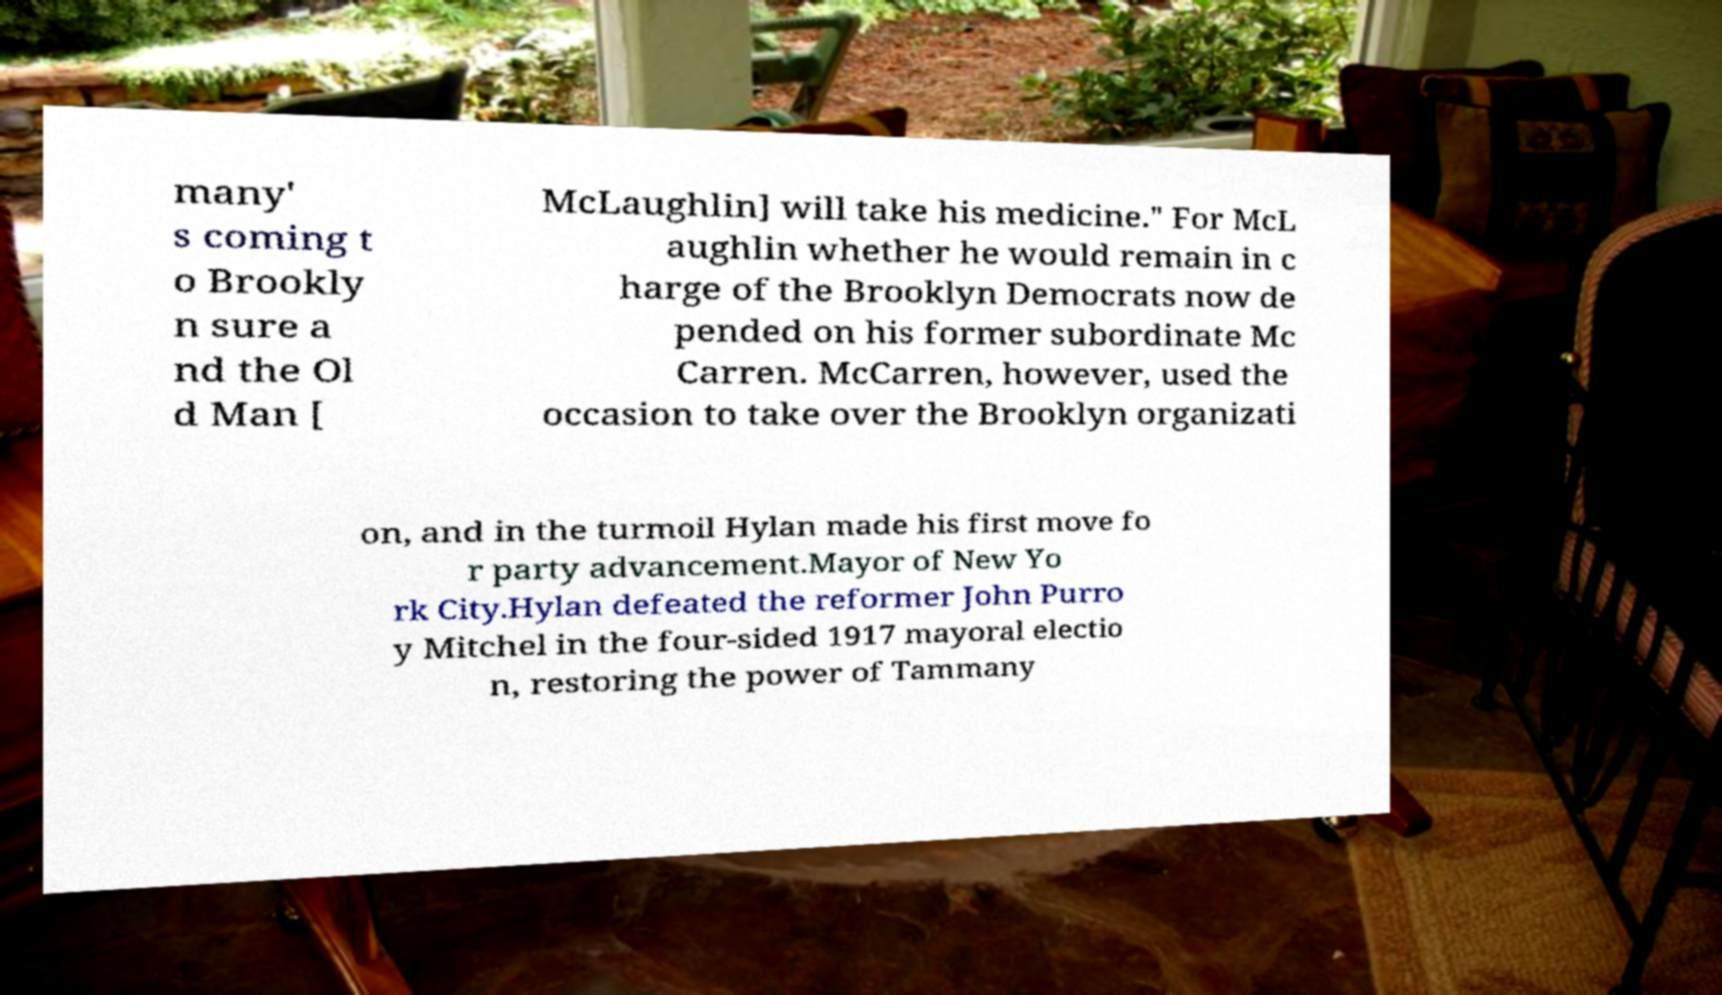There's text embedded in this image that I need extracted. Can you transcribe it verbatim? many' s coming t o Brookly n sure a nd the Ol d Man [ McLaughlin] will take his medicine." For McL aughlin whether he would remain in c harge of the Brooklyn Democrats now de pended on his former subordinate Mc Carren. McCarren, however, used the occasion to take over the Brooklyn organizati on, and in the turmoil Hylan made his first move fo r party advancement.Mayor of New Yo rk City.Hylan defeated the reformer John Purro y Mitchel in the four-sided 1917 mayoral electio n, restoring the power of Tammany 